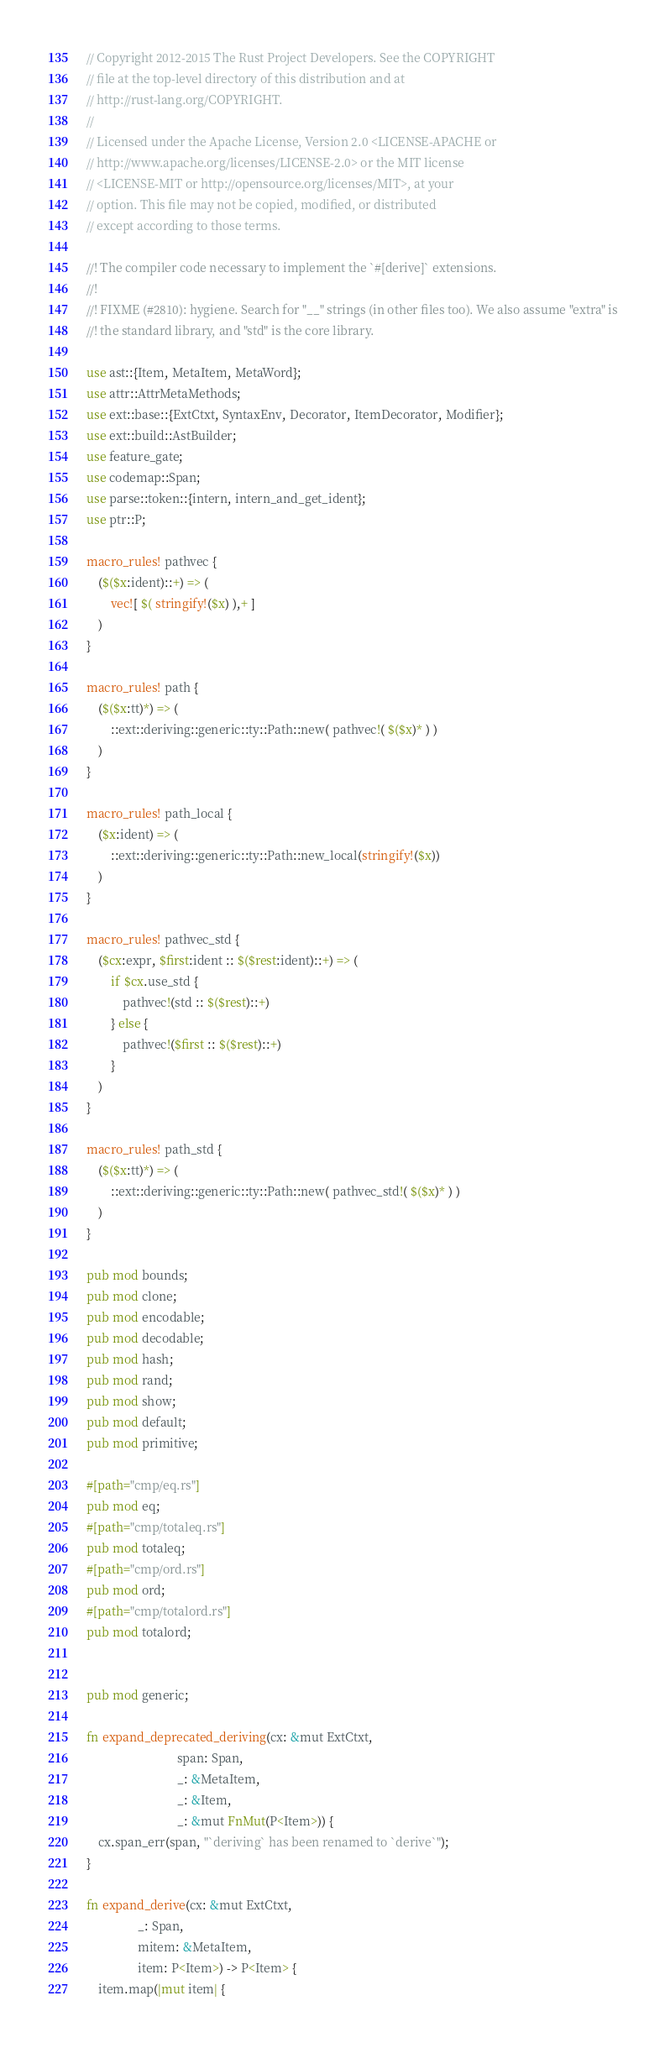<code> <loc_0><loc_0><loc_500><loc_500><_Rust_>// Copyright 2012-2015 The Rust Project Developers. See the COPYRIGHT
// file at the top-level directory of this distribution and at
// http://rust-lang.org/COPYRIGHT.
//
// Licensed under the Apache License, Version 2.0 <LICENSE-APACHE or
// http://www.apache.org/licenses/LICENSE-2.0> or the MIT license
// <LICENSE-MIT or http://opensource.org/licenses/MIT>, at your
// option. This file may not be copied, modified, or distributed
// except according to those terms.

//! The compiler code necessary to implement the `#[derive]` extensions.
//!
//! FIXME (#2810): hygiene. Search for "__" strings (in other files too). We also assume "extra" is
//! the standard library, and "std" is the core library.

use ast::{Item, MetaItem, MetaWord};
use attr::AttrMetaMethods;
use ext::base::{ExtCtxt, SyntaxEnv, Decorator, ItemDecorator, Modifier};
use ext::build::AstBuilder;
use feature_gate;
use codemap::Span;
use parse::token::{intern, intern_and_get_ident};
use ptr::P;

macro_rules! pathvec {
    ($($x:ident)::+) => (
        vec![ $( stringify!($x) ),+ ]
    )
}

macro_rules! path {
    ($($x:tt)*) => (
        ::ext::deriving::generic::ty::Path::new( pathvec!( $($x)* ) )
    )
}

macro_rules! path_local {
    ($x:ident) => (
        ::ext::deriving::generic::ty::Path::new_local(stringify!($x))
    )
}

macro_rules! pathvec_std {
    ($cx:expr, $first:ident :: $($rest:ident)::+) => (
        if $cx.use_std {
            pathvec!(std :: $($rest)::+)
        } else {
            pathvec!($first :: $($rest)::+)
        }
    )
}

macro_rules! path_std {
    ($($x:tt)*) => (
        ::ext::deriving::generic::ty::Path::new( pathvec_std!( $($x)* ) )
    )
}

pub mod bounds;
pub mod clone;
pub mod encodable;
pub mod decodable;
pub mod hash;
pub mod rand;
pub mod show;
pub mod default;
pub mod primitive;

#[path="cmp/eq.rs"]
pub mod eq;
#[path="cmp/totaleq.rs"]
pub mod totaleq;
#[path="cmp/ord.rs"]
pub mod ord;
#[path="cmp/totalord.rs"]
pub mod totalord;


pub mod generic;

fn expand_deprecated_deriving(cx: &mut ExtCtxt,
                              span: Span,
                              _: &MetaItem,
                              _: &Item,
                              _: &mut FnMut(P<Item>)) {
    cx.span_err(span, "`deriving` has been renamed to `derive`");
}

fn expand_derive(cx: &mut ExtCtxt,
                 _: Span,
                 mitem: &MetaItem,
                 item: P<Item>) -> P<Item> {
    item.map(|mut item| {</code> 